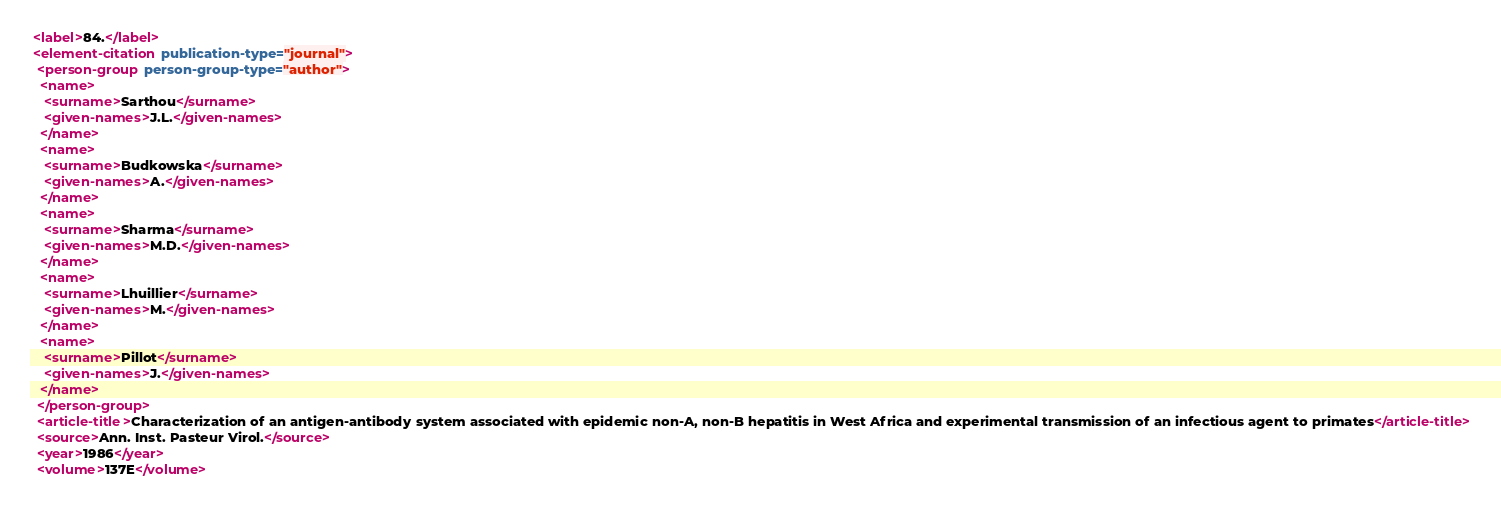Convert code to text. <code><loc_0><loc_0><loc_500><loc_500><_XML_> <label>84.</label>
 <element-citation publication-type="journal">
  <person-group person-group-type="author">
   <name>
    <surname>Sarthou</surname>
    <given-names>J.L.</given-names>
   </name>
   <name>
    <surname>Budkowska</surname>
    <given-names>A.</given-names>
   </name>
   <name>
    <surname>Sharma</surname>
    <given-names>M.D.</given-names>
   </name>
   <name>
    <surname>Lhuillier</surname>
    <given-names>M.</given-names>
   </name>
   <name>
    <surname>Pillot</surname>
    <given-names>J.</given-names>
   </name>
  </person-group>
  <article-title>Characterization of an antigen-antibody system associated with epidemic non-A, non-B hepatitis in West Africa and experimental transmission of an infectious agent to primates</article-title>
  <source>Ann. Inst. Pasteur Virol.</source>
  <year>1986</year>
  <volume>137E</volume></code> 